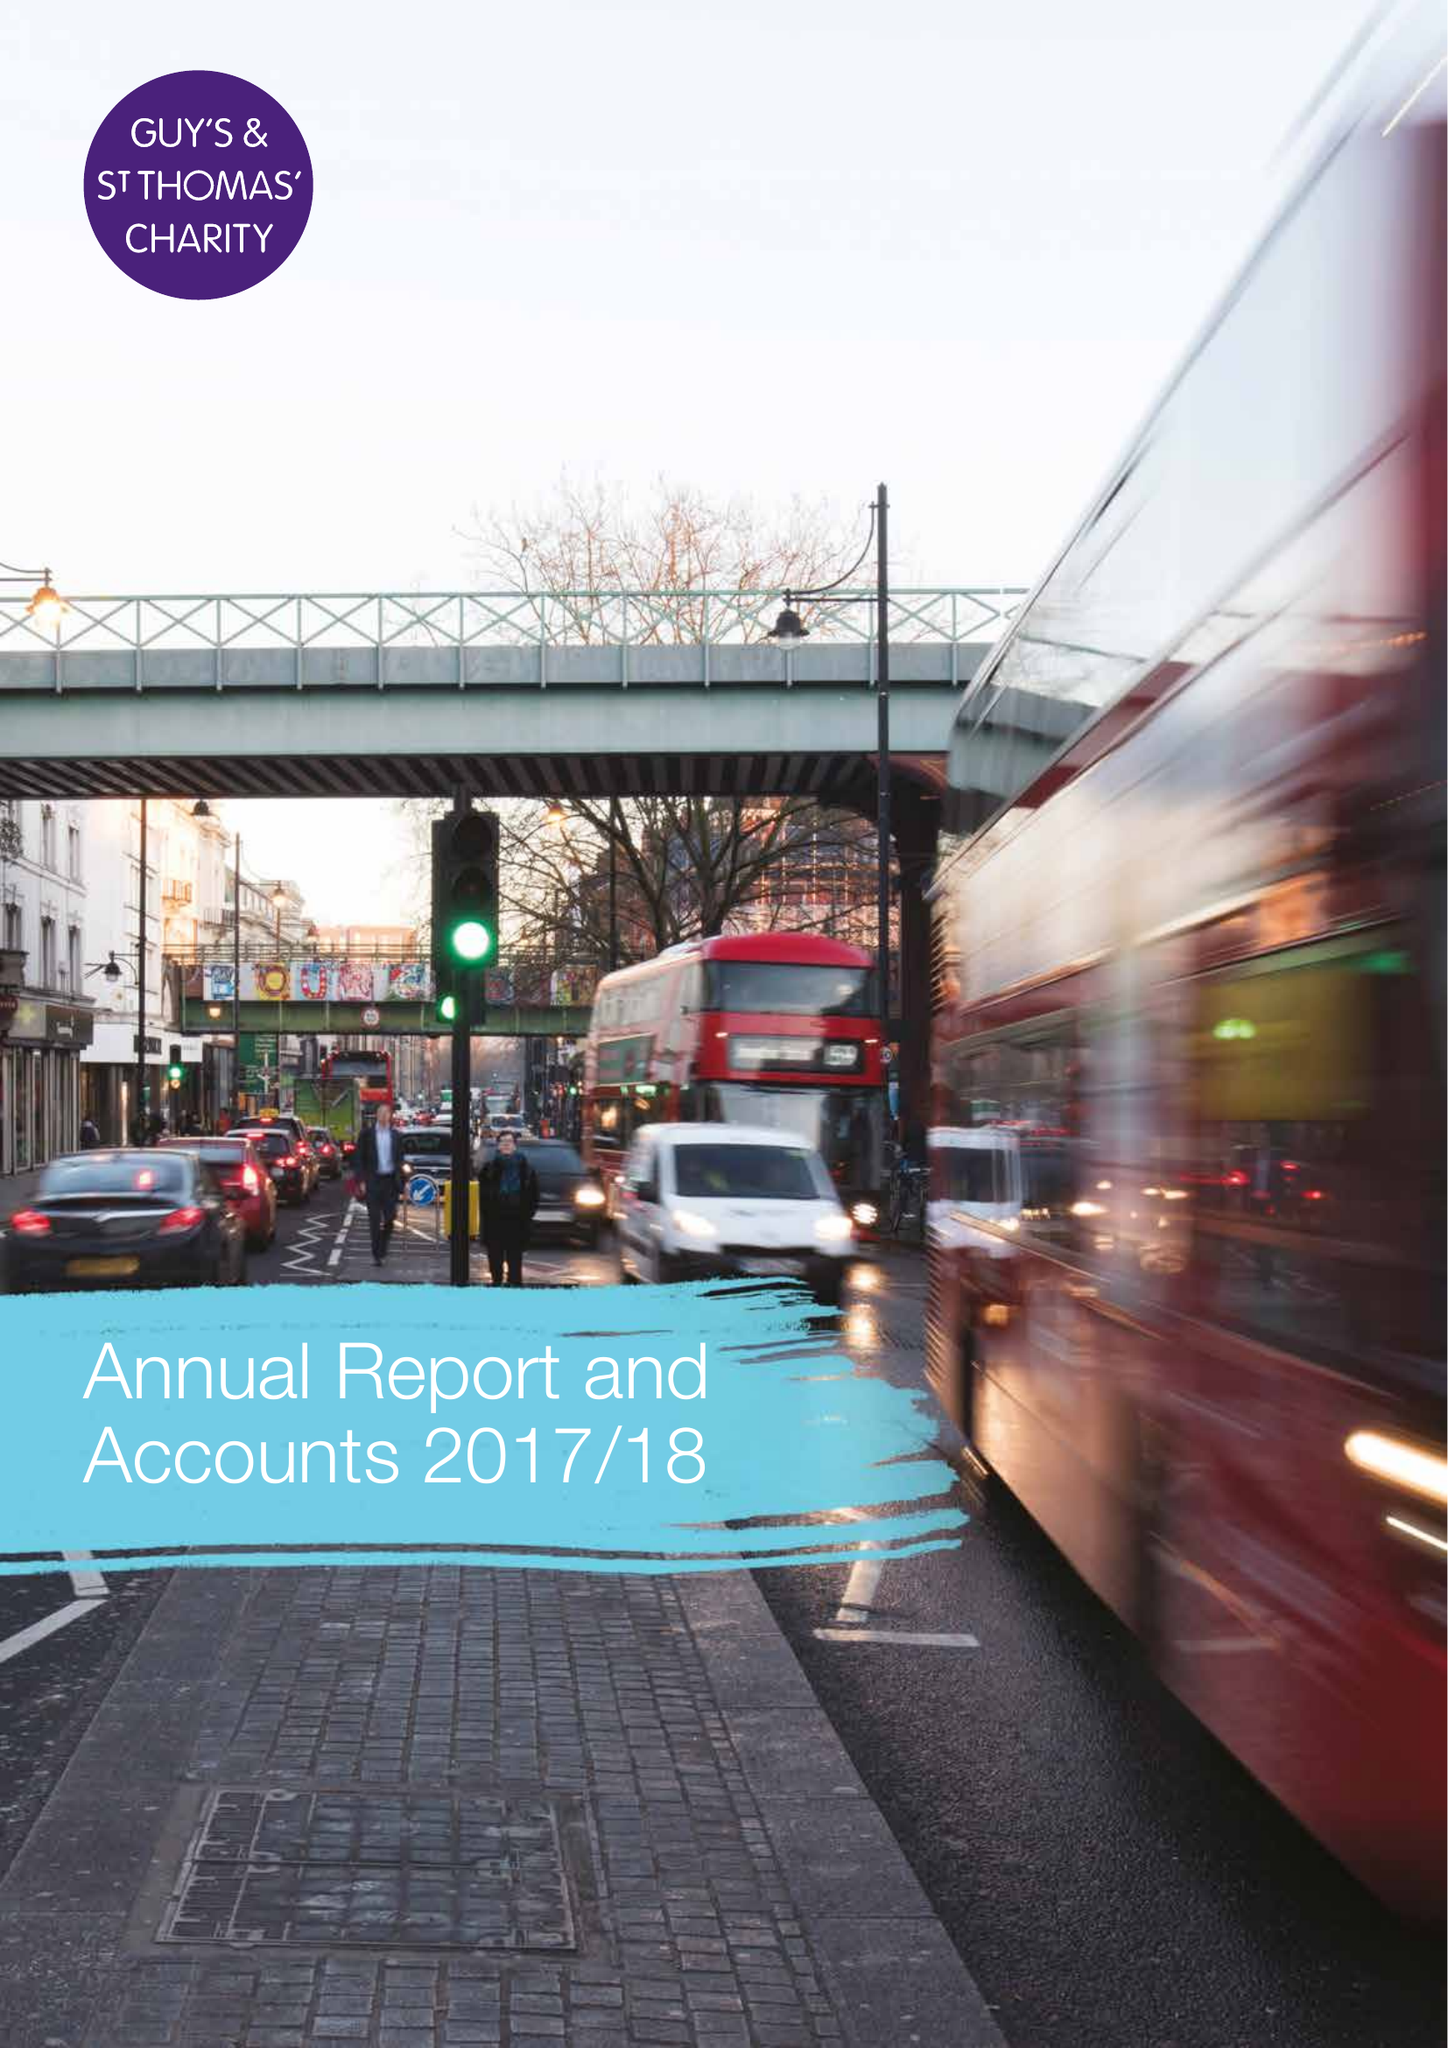What is the value for the address__post_town?
Answer the question using a single word or phrase. LONDON 